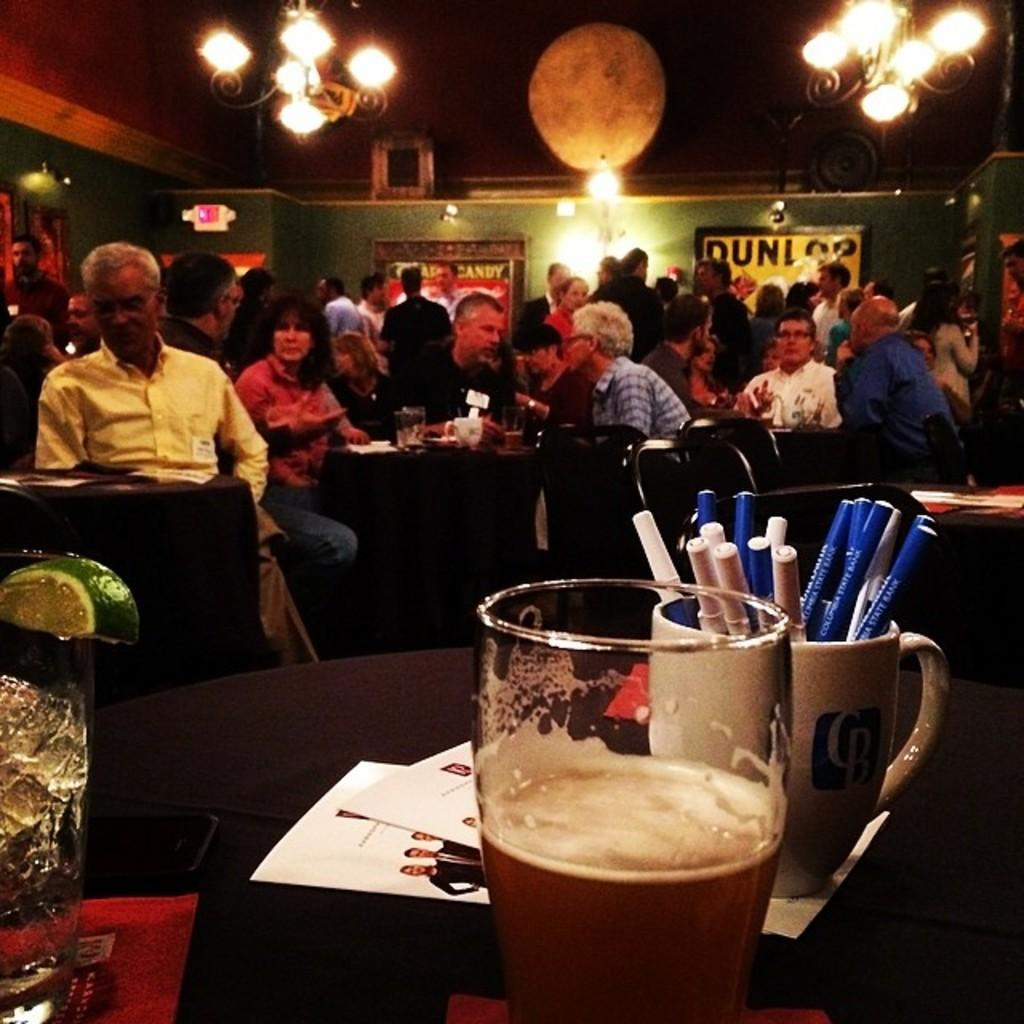<image>
Offer a succinct explanation of the picture presented. People in a crowded bar; the word candy can be seen on a poster. 